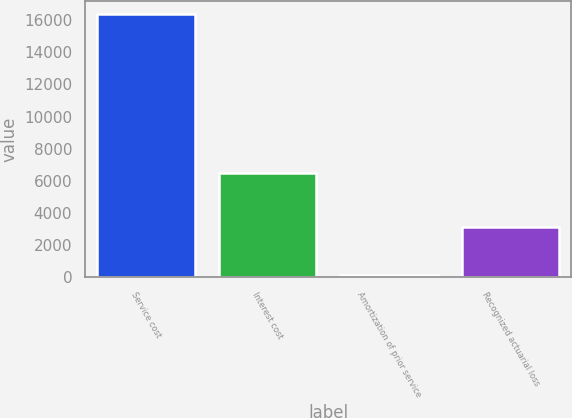Convert chart. <chart><loc_0><loc_0><loc_500><loc_500><bar_chart><fcel>Service cost<fcel>Interest cost<fcel>Amortization of prior service<fcel>Recognized actuarial loss<nl><fcel>16358<fcel>6464<fcel>156<fcel>3145<nl></chart> 